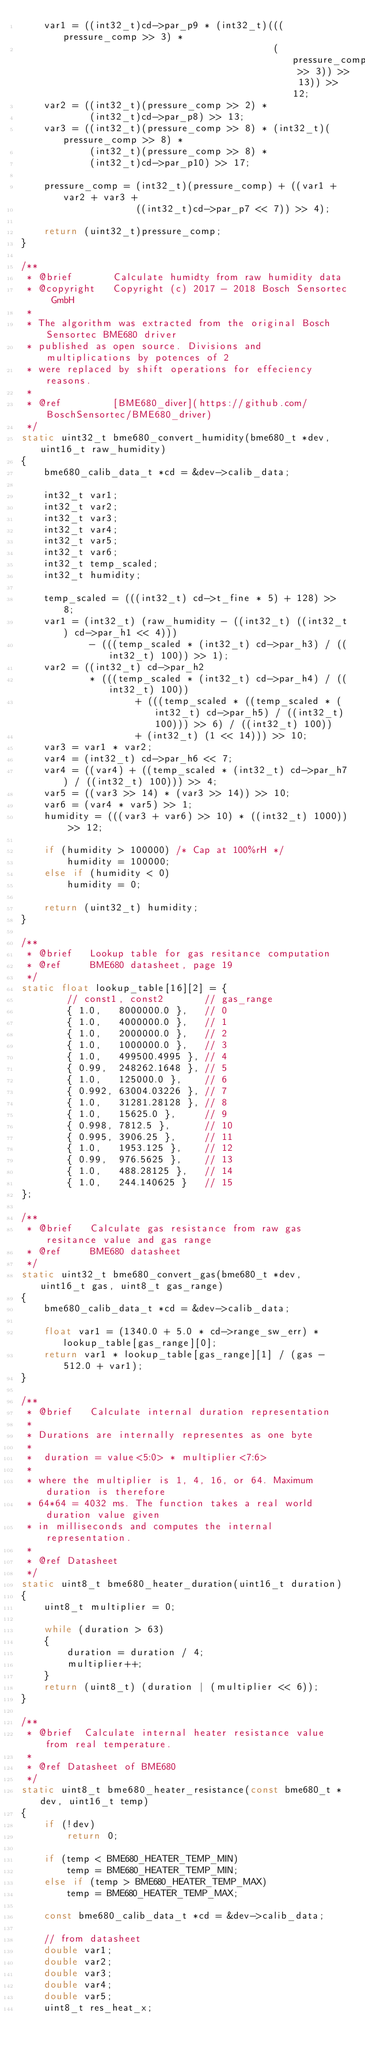<code> <loc_0><loc_0><loc_500><loc_500><_C_>    var1 = ((int32_t)cd->par_p9 * (int32_t)(((pressure_comp >> 3) *
                                            (pressure_comp >> 3)) >> 13)) >> 12;
    var2 = ((int32_t)(pressure_comp >> 2) *
            (int32_t)cd->par_p8) >> 13;
    var3 = ((int32_t)(pressure_comp >> 8) * (int32_t)(pressure_comp >> 8) *
            (int32_t)(pressure_comp >> 8) *
            (int32_t)cd->par_p10) >> 17;

    pressure_comp = (int32_t)(pressure_comp) + ((var1 + var2 + var3 +
                    ((int32_t)cd->par_p7 << 7)) >> 4);

    return (uint32_t)pressure_comp;
}

/**
 * @brief       Calculate humidty from raw humidity data
 * @copyright   Copyright (c) 2017 - 2018 Bosch Sensortec GmbH
 *
 * The algorithm was extracted from the original Bosch Sensortec BME680 driver
 * published as open source. Divisions and multiplications by potences of 2
 * were replaced by shift operations for effeciency reasons.
 *
 * @ref         [BME680_diver](https://github.com/BoschSensortec/BME680_driver)
 */
static uint32_t bme680_convert_humidity(bme680_t *dev, uint16_t raw_humidity)
{
    bme680_calib_data_t *cd = &dev->calib_data;

    int32_t var1;
    int32_t var2;
    int32_t var3;
    int32_t var4;
    int32_t var5;
    int32_t var6;
    int32_t temp_scaled;
    int32_t humidity;

    temp_scaled = (((int32_t) cd->t_fine * 5) + 128) >> 8;
    var1 = (int32_t) (raw_humidity - ((int32_t) ((int32_t) cd->par_h1 << 4)))
            - (((temp_scaled * (int32_t) cd->par_h3) / ((int32_t) 100)) >> 1);
    var2 = ((int32_t) cd->par_h2
            * (((temp_scaled * (int32_t) cd->par_h4) / ((int32_t) 100))
                    + (((temp_scaled * ((temp_scaled * (int32_t) cd->par_h5) / ((int32_t) 100))) >> 6) / ((int32_t) 100))
                    + (int32_t) (1 << 14))) >> 10;
    var3 = var1 * var2;
    var4 = (int32_t) cd->par_h6 << 7;
    var4 = ((var4) + ((temp_scaled * (int32_t) cd->par_h7) / ((int32_t) 100))) >> 4;
    var5 = ((var3 >> 14) * (var3 >> 14)) >> 10;
    var6 = (var4 * var5) >> 1;
    humidity = (((var3 + var6) >> 10) * ((int32_t) 1000)) >> 12;

    if (humidity > 100000) /* Cap at 100%rH */
        humidity = 100000;
    else if (humidity < 0)
        humidity = 0;

    return (uint32_t) humidity;
}

/**
 * @brief   Lookup table for gas resitance computation
 * @ref     BME680 datasheet, page 19
 */
static float lookup_table[16][2] = {
        // const1, const2       // gas_range
        { 1.0,   8000000.0 },   // 0
        { 1.0,   4000000.0 },   // 1
        { 1.0,   2000000.0 },   // 2
        { 1.0,   1000000.0 },   // 3
        { 1.0,   499500.4995 }, // 4
        { 0.99,  248262.1648 }, // 5
        { 1.0,   125000.0 },    // 6
        { 0.992, 63004.03226 }, // 7
        { 1.0,   31281.28128 }, // 8
        { 1.0,   15625.0 },     // 9
        { 0.998, 7812.5 },      // 10
        { 0.995, 3906.25 },     // 11
        { 1.0,   1953.125 },    // 12
        { 0.99,  976.5625 },    // 13
        { 1.0,   488.28125 },   // 14
        { 1.0,   244.140625 }   // 15
};

/**
 * @brief   Calculate gas resistance from raw gas resitance value and gas range
 * @ref     BME680 datasheet
 */
static uint32_t bme680_convert_gas(bme680_t *dev, uint16_t gas, uint8_t gas_range)
{
    bme680_calib_data_t *cd = &dev->calib_data;

    float var1 = (1340.0 + 5.0 * cd->range_sw_err) * lookup_table[gas_range][0];
    return var1 * lookup_table[gas_range][1] / (gas - 512.0 + var1);
}

/**
 * @brief   Calculate internal duration representation
 *
 * Durations are internally representes as one byte
 *
 *  duration = value<5:0> * multiplier<7:6>
 *
 * where the multiplier is 1, 4, 16, or 64. Maximum duration is therefore
 * 64*64 = 4032 ms. The function takes a real world duration value given
 * in milliseconds and computes the internal representation.
 *
 * @ref Datasheet
 */
static uint8_t bme680_heater_duration(uint16_t duration)
{
    uint8_t multiplier = 0;

    while (duration > 63)
    {
        duration = duration / 4;
        multiplier++;
    }
    return (uint8_t) (duration | (multiplier << 6));
}

/**
 * @brief  Calculate internal heater resistance value from real temperature.
 *
 * @ref Datasheet of BME680
 */
static uint8_t bme680_heater_resistance(const bme680_t *dev, uint16_t temp)
{
    if (!dev)
        return 0;

    if (temp < BME680_HEATER_TEMP_MIN)
        temp = BME680_HEATER_TEMP_MIN;
    else if (temp > BME680_HEATER_TEMP_MAX)
        temp = BME680_HEATER_TEMP_MAX;

    const bme680_calib_data_t *cd = &dev->calib_data;

    // from datasheet
    double var1;
    double var2;
    double var3;
    double var4;
    double var5;
    uint8_t res_heat_x;
</code> 